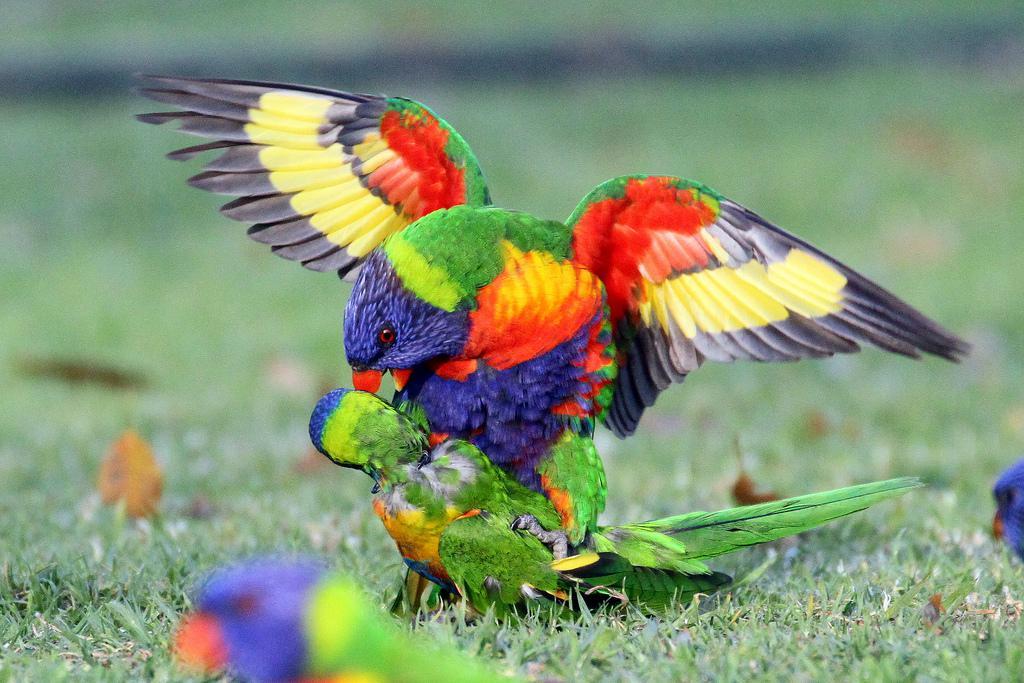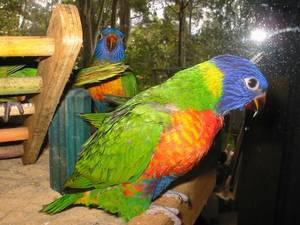The first image is the image on the left, the second image is the image on the right. Considering the images on both sides, is "An image shows a parrot with spread wings on top of a parrot that is on the ground." valid? Answer yes or no. Yes. The first image is the image on the left, the second image is the image on the right. For the images shown, is this caption "There are three birds with blue head." true? Answer yes or no. Yes. 